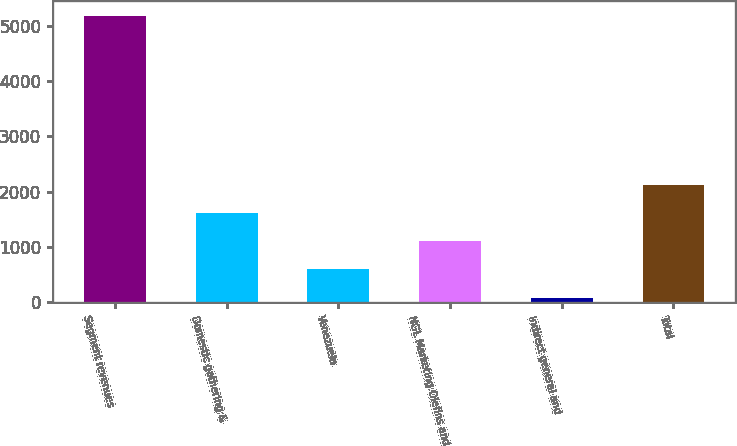Convert chart to OTSL. <chart><loc_0><loc_0><loc_500><loc_500><bar_chart><fcel>Segment revenues<fcel>Domestic gathering &<fcel>Venezuela<fcel>NGL Marketing Olefins and<fcel>Indirect general and<fcel>Total<nl><fcel>5180<fcel>1615.6<fcel>597.2<fcel>1106.4<fcel>88<fcel>2124.8<nl></chart> 